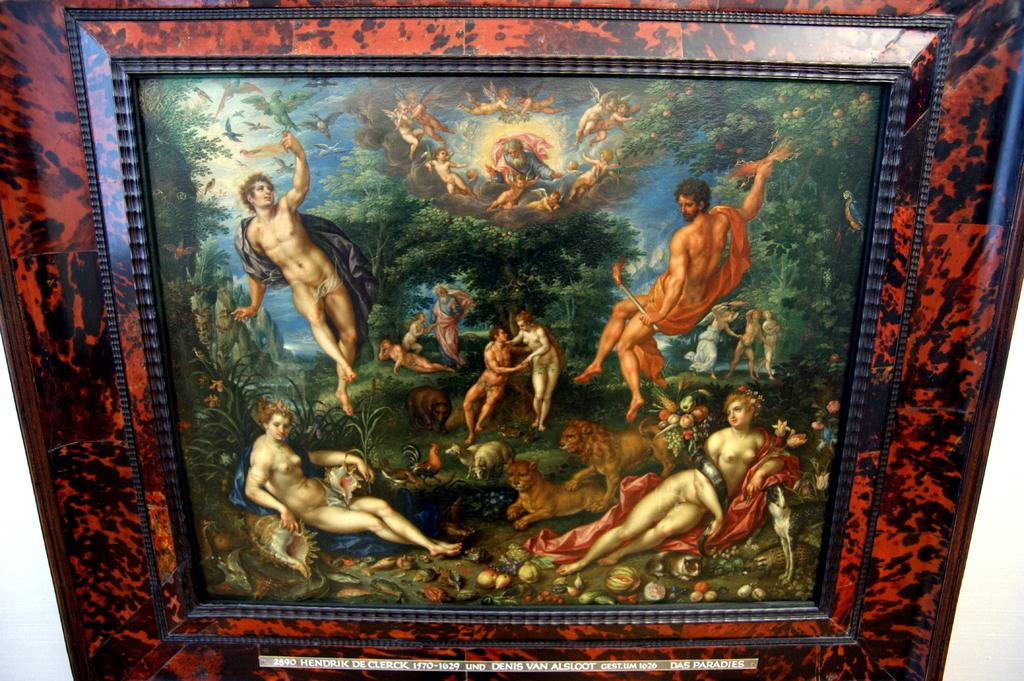<image>
Relay a brief, clear account of the picture shown. Hendrik De Clerck 1570-1629 was the artist of the naked people painting 